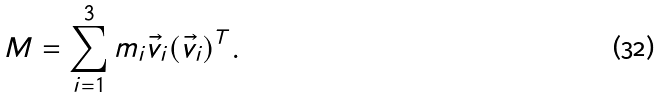<formula> <loc_0><loc_0><loc_500><loc_500>M = \sum _ { i = 1 } ^ { 3 } m _ { i } \vec { v } _ { i } ( \vec { v } _ { i } ) ^ { T } .</formula> 